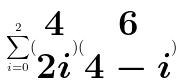<formula> <loc_0><loc_0><loc_500><loc_500>\sum _ { i = 0 } ^ { 2 } ( \begin{matrix} 4 \\ 2 i \end{matrix} ) ( \begin{matrix} 6 \\ 4 - i \end{matrix} )</formula> 